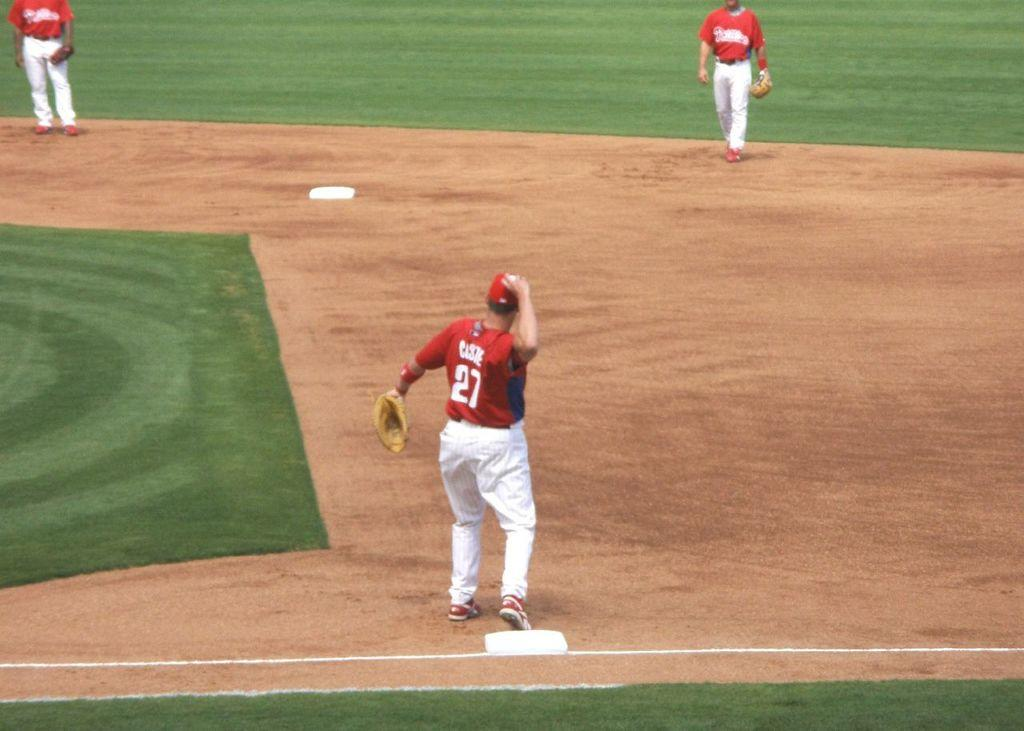<image>
Create a compact narrative representing the image presented. The number 27 is on the back of a baseball player's shirt. 